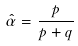Convert formula to latex. <formula><loc_0><loc_0><loc_500><loc_500>\hat { \alpha } = \frac { p } { p + q }</formula> 